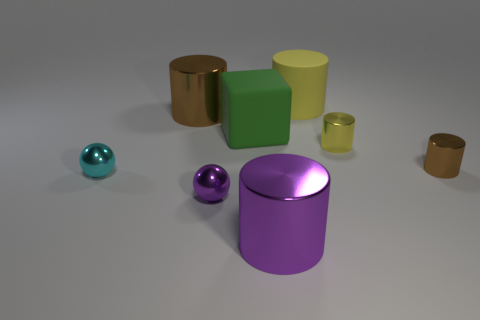There is a matte cylinder; is it the same color as the small cylinder on the left side of the small brown cylinder?
Keep it short and to the point. Yes. What number of other objects are there of the same color as the matte cylinder?
Provide a succinct answer. 1. Are there fewer purple shiny cubes than shiny things?
Your response must be concise. Yes. There is a yellow object that is in front of the matte object in front of the big yellow rubber thing; how many shiny objects are in front of it?
Give a very brief answer. 4. How big is the yellow object in front of the big yellow matte cylinder?
Give a very brief answer. Small. Does the brown object left of the big yellow object have the same shape as the tiny brown object?
Ensure brevity in your answer.  Yes. There is another small thing that is the same shape as the tiny yellow object; what is it made of?
Provide a short and direct response. Metal. Are there any yellow rubber spheres?
Your answer should be compact. No. There is a yellow object that is behind the yellow object in front of the brown object that is behind the small brown metal thing; what is its material?
Your answer should be compact. Rubber. There is a small cyan thing; does it have the same shape as the small metallic object that is in front of the tiny cyan metallic object?
Provide a short and direct response. Yes. 